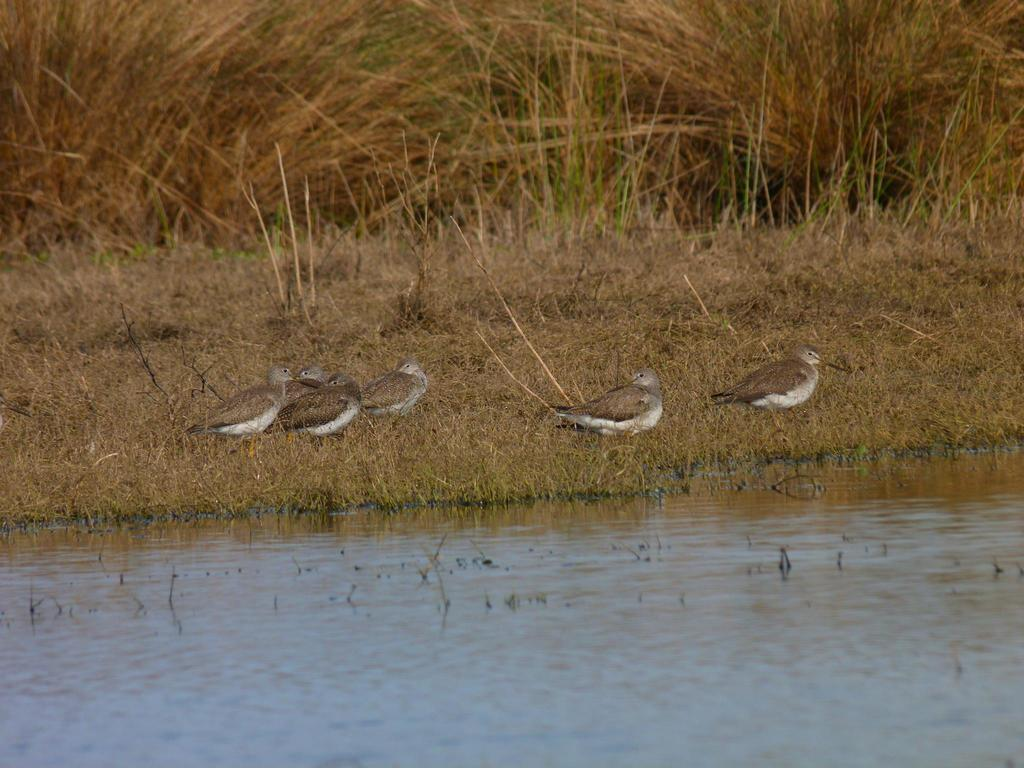What is visible in the image? There is water and birds on the grass visible in the image. Can you describe the birds in the image? The birds are on the grass in the image. What type of environment is depicted in the image? The image shows a natural environment with water and grass. What type of stick can be seen coiled around the nerves of the birds in the image? There is no stick or coiled nerves present in the image; it features birds on the grass near water. 